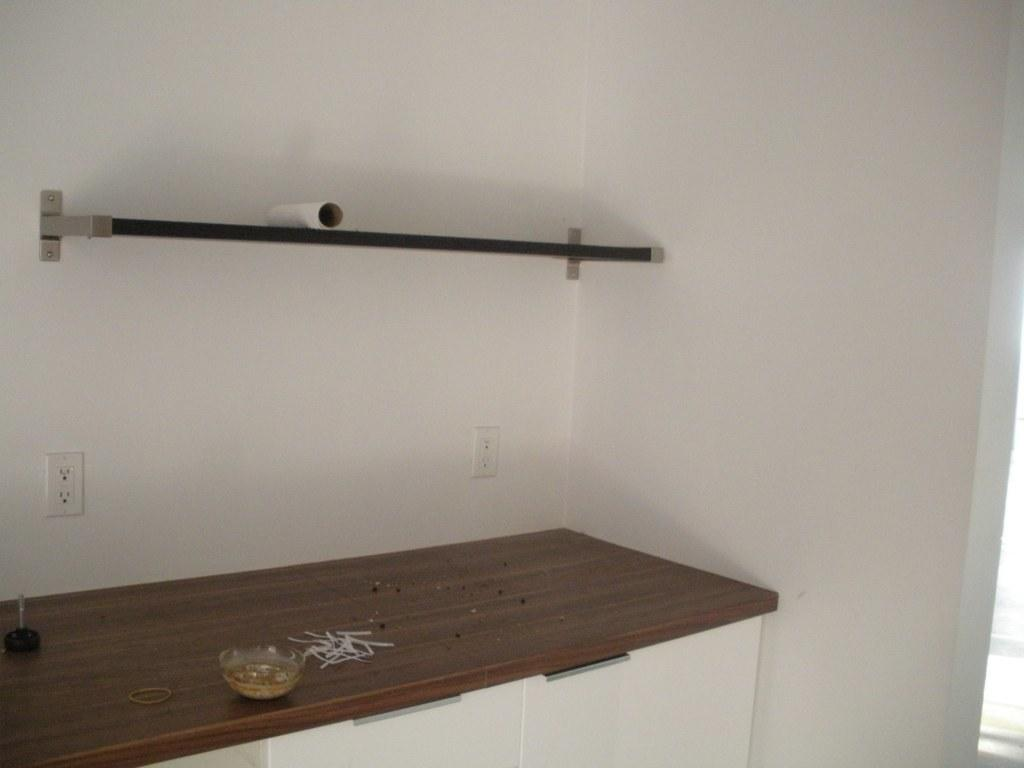What type of container is visible in the image? There is a glass bowl in the image. What else can be seen on the surface where the glass bowl is located? There are other items on a surface in the image. What type of storage units are present below the surface? There are white cupboards below the surface. What can be found on the wall in the image? There are sockets on the wall and a ledge shelf. What type of root system can be seen growing from the glass bowl in the image? There is no root system visible in the image, as it features a glass bowl and other items on a surface. 